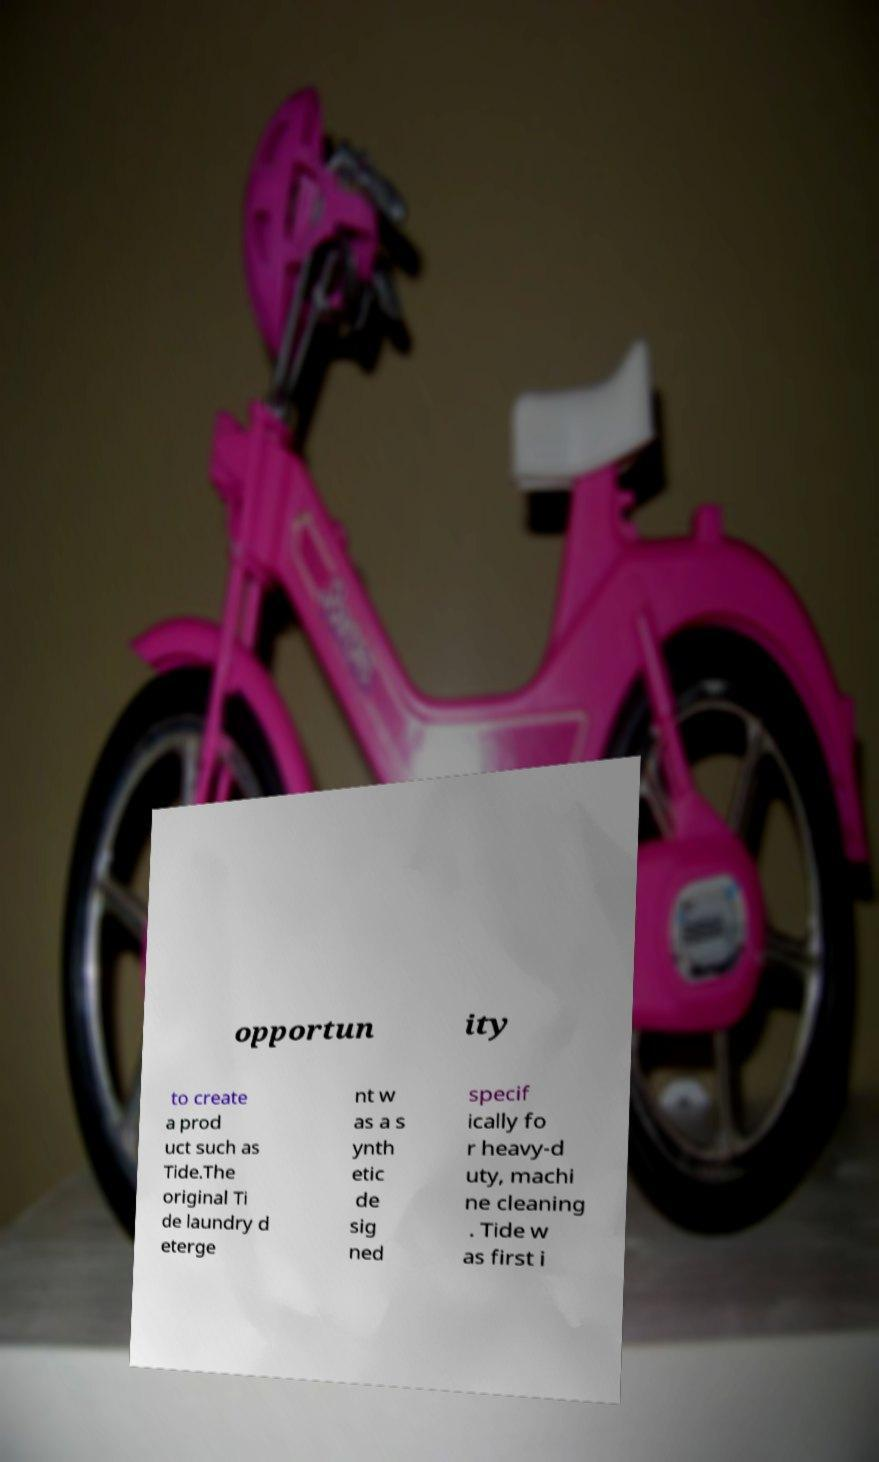Can you read and provide the text displayed in the image?This photo seems to have some interesting text. Can you extract and type it out for me? opportun ity to create a prod uct such as Tide.The original Ti de laundry d eterge nt w as a s ynth etic de sig ned specif ically fo r heavy-d uty, machi ne cleaning . Tide w as first i 